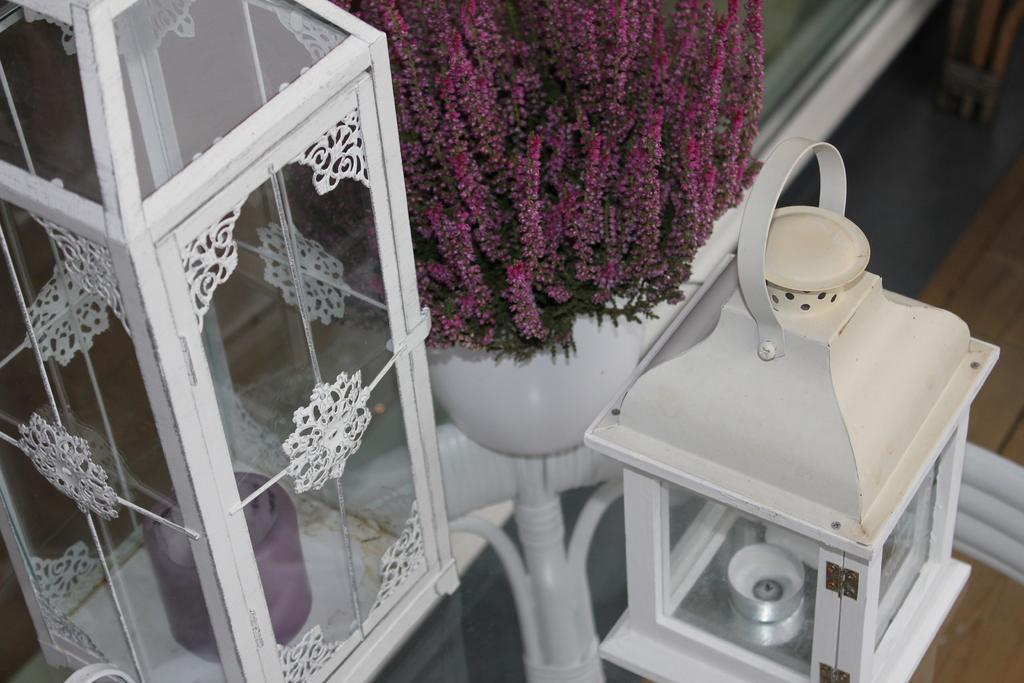What type of table is in the image? There is a glass table in the image. What objects are on the table? There are candles on the table. How are the candles contained or protected? The candles are in a glass box. Are there any visible brake mechanisms on the glass table in the image? No, there are no visible brake mechanisms on the glass table in the image. 